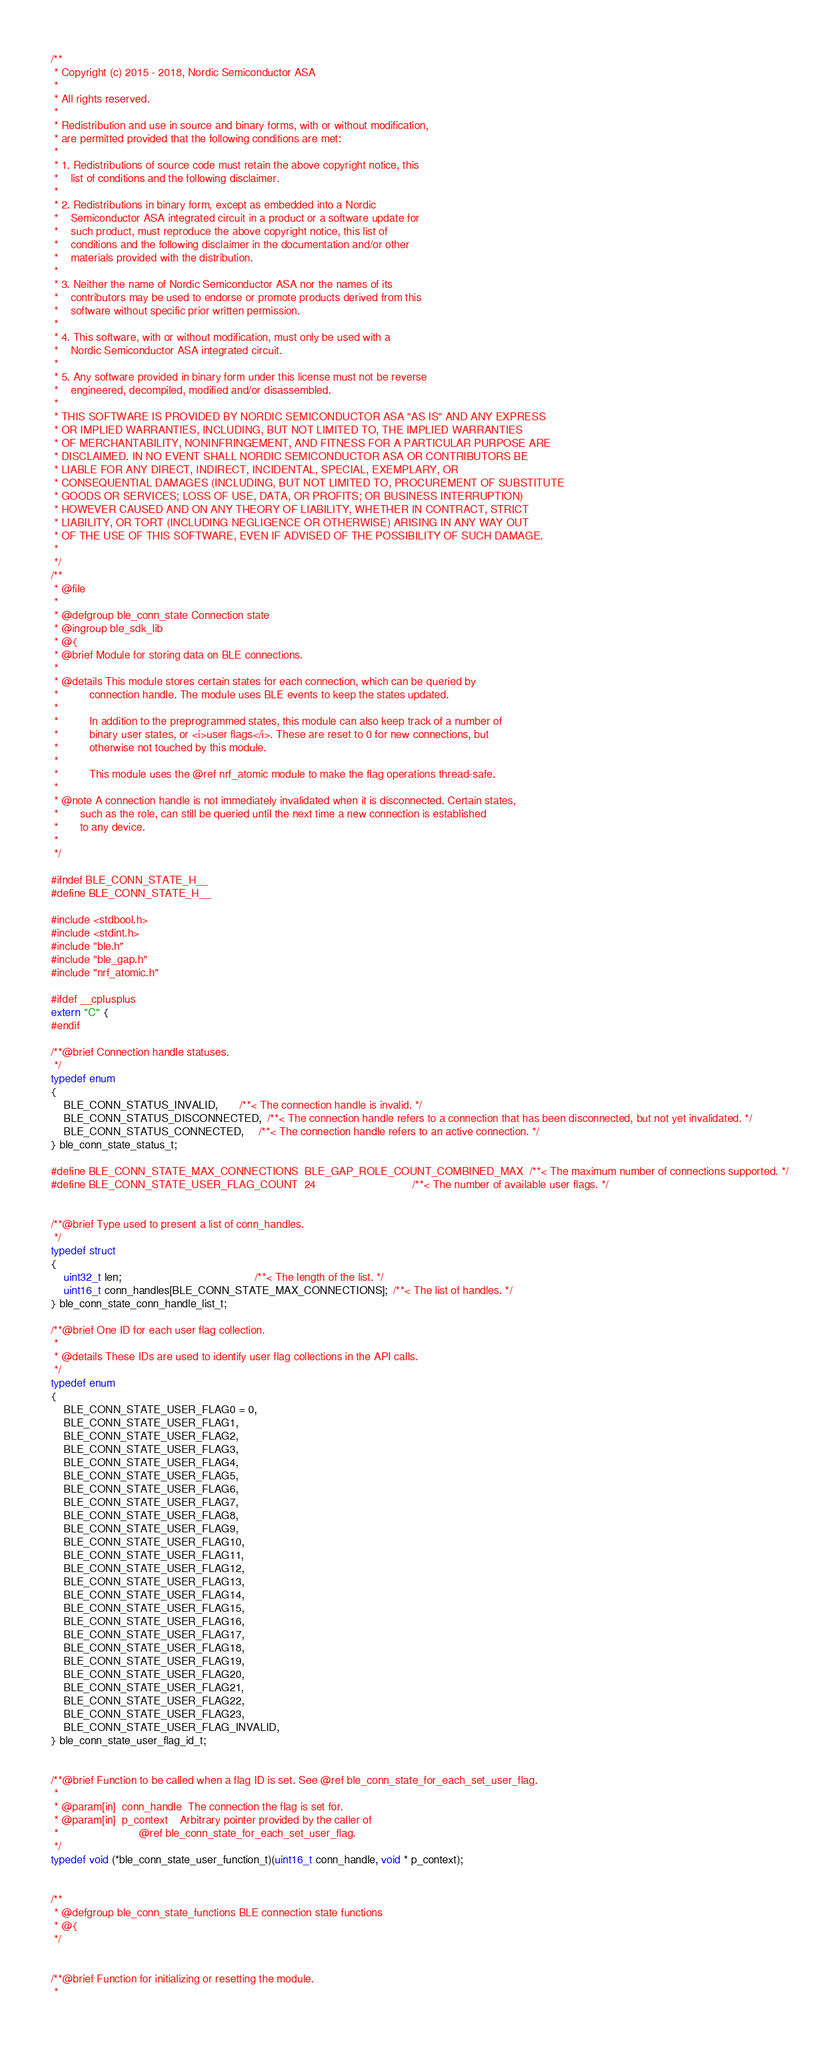<code> <loc_0><loc_0><loc_500><loc_500><_C_>/**
 * Copyright (c) 2015 - 2018, Nordic Semiconductor ASA
 *
 * All rights reserved.
 *
 * Redistribution and use in source and binary forms, with or without modification,
 * are permitted provided that the following conditions are met:
 *
 * 1. Redistributions of source code must retain the above copyright notice, this
 *    list of conditions and the following disclaimer.
 *
 * 2. Redistributions in binary form, except as embedded into a Nordic
 *    Semiconductor ASA integrated circuit in a product or a software update for
 *    such product, must reproduce the above copyright notice, this list of
 *    conditions and the following disclaimer in the documentation and/or other
 *    materials provided with the distribution.
 *
 * 3. Neither the name of Nordic Semiconductor ASA nor the names of its
 *    contributors may be used to endorse or promote products derived from this
 *    software without specific prior written permission.
 *
 * 4. This software, with or without modification, must only be used with a
 *    Nordic Semiconductor ASA integrated circuit.
 *
 * 5. Any software provided in binary form under this license must not be reverse
 *    engineered, decompiled, modified and/or disassembled.
 *
 * THIS SOFTWARE IS PROVIDED BY NORDIC SEMICONDUCTOR ASA "AS IS" AND ANY EXPRESS
 * OR IMPLIED WARRANTIES, INCLUDING, BUT NOT LIMITED TO, THE IMPLIED WARRANTIES
 * OF MERCHANTABILITY, NONINFRINGEMENT, AND FITNESS FOR A PARTICULAR PURPOSE ARE
 * DISCLAIMED. IN NO EVENT SHALL NORDIC SEMICONDUCTOR ASA OR CONTRIBUTORS BE
 * LIABLE FOR ANY DIRECT, INDIRECT, INCIDENTAL, SPECIAL, EXEMPLARY, OR
 * CONSEQUENTIAL DAMAGES (INCLUDING, BUT NOT LIMITED TO, PROCUREMENT OF SUBSTITUTE
 * GOODS OR SERVICES; LOSS OF USE, DATA, OR PROFITS; OR BUSINESS INTERRUPTION)
 * HOWEVER CAUSED AND ON ANY THEORY OF LIABILITY, WHETHER IN CONTRACT, STRICT
 * LIABILITY, OR TORT (INCLUDING NEGLIGENCE OR OTHERWISE) ARISING IN ANY WAY OUT
 * OF THE USE OF THIS SOFTWARE, EVEN IF ADVISED OF THE POSSIBILITY OF SUCH DAMAGE.
 *
 */
/**
 * @file
 *
 * @defgroup ble_conn_state Connection state
 * @ingroup ble_sdk_lib
 * @{
 * @brief Module for storing data on BLE connections.
 *
 * @details This module stores certain states for each connection, which can be queried by
 *          connection handle. The module uses BLE events to keep the states updated.
 *
 *          In addition to the preprogrammed states, this module can also keep track of a number of
 *          binary user states, or <i>user flags</i>. These are reset to 0 for new connections, but
 *          otherwise not touched by this module.
 *
 *          This module uses the @ref nrf_atomic module to make the flag operations thread-safe.
 *
 * @note A connection handle is not immediately invalidated when it is disconnected. Certain states,
 *       such as the role, can still be queried until the next time a new connection is established
 *       to any device.
 *
 */

#ifndef BLE_CONN_STATE_H__
#define BLE_CONN_STATE_H__

#include <stdbool.h>
#include <stdint.h>
#include "ble.h"
#include "ble_gap.h"
#include "nrf_atomic.h"

#ifdef __cplusplus
extern "C" {
#endif

/**@brief Connection handle statuses.
 */
typedef enum
{
    BLE_CONN_STATUS_INVALID,       /**< The connection handle is invalid. */
    BLE_CONN_STATUS_DISCONNECTED,  /**< The connection handle refers to a connection that has been disconnected, but not yet invalidated. */
    BLE_CONN_STATUS_CONNECTED,     /**< The connection handle refers to an active connection. */
} ble_conn_state_status_t;

#define BLE_CONN_STATE_MAX_CONNECTIONS  BLE_GAP_ROLE_COUNT_COMBINED_MAX  /**< The maximum number of connections supported. */
#define BLE_CONN_STATE_USER_FLAG_COUNT  24                               /**< The number of available user flags. */


/**@brief Type used to present a list of conn_handles.
 */
typedef struct
{
    uint32_t len;                                           /**< The length of the list. */
    uint16_t conn_handles[BLE_CONN_STATE_MAX_CONNECTIONS];  /**< The list of handles. */
} ble_conn_state_conn_handle_list_t;

/**@brief One ID for each user flag collection.
 *
 * @details These IDs are used to identify user flag collections in the API calls.
 */
typedef enum
{
    BLE_CONN_STATE_USER_FLAG0 = 0,
    BLE_CONN_STATE_USER_FLAG1,
    BLE_CONN_STATE_USER_FLAG2,
    BLE_CONN_STATE_USER_FLAG3,
    BLE_CONN_STATE_USER_FLAG4,
    BLE_CONN_STATE_USER_FLAG5,
    BLE_CONN_STATE_USER_FLAG6,
    BLE_CONN_STATE_USER_FLAG7,
    BLE_CONN_STATE_USER_FLAG8,
    BLE_CONN_STATE_USER_FLAG9,
    BLE_CONN_STATE_USER_FLAG10,
    BLE_CONN_STATE_USER_FLAG11,
    BLE_CONN_STATE_USER_FLAG12,
    BLE_CONN_STATE_USER_FLAG13,
    BLE_CONN_STATE_USER_FLAG14,
    BLE_CONN_STATE_USER_FLAG15,
    BLE_CONN_STATE_USER_FLAG16,
    BLE_CONN_STATE_USER_FLAG17,
    BLE_CONN_STATE_USER_FLAG18,
    BLE_CONN_STATE_USER_FLAG19,
    BLE_CONN_STATE_USER_FLAG20,
    BLE_CONN_STATE_USER_FLAG21,
    BLE_CONN_STATE_USER_FLAG22,
    BLE_CONN_STATE_USER_FLAG23,
    BLE_CONN_STATE_USER_FLAG_INVALID,
} ble_conn_state_user_flag_id_t;


/**@brief Function to be called when a flag ID is set. See @ref ble_conn_state_for_each_set_user_flag.
 *
 * @param[in]  conn_handle  The connection the flag is set for.
 * @param[in]  p_context    Arbitrary pointer provided by the caller of
 *                          @ref ble_conn_state_for_each_set_user_flag.
 */
typedef void (*ble_conn_state_user_function_t)(uint16_t conn_handle, void * p_context);


/**
 * @defgroup ble_conn_state_functions BLE connection state functions
 * @{
 */


/**@brief Function for initializing or resetting the module.
 *</code> 